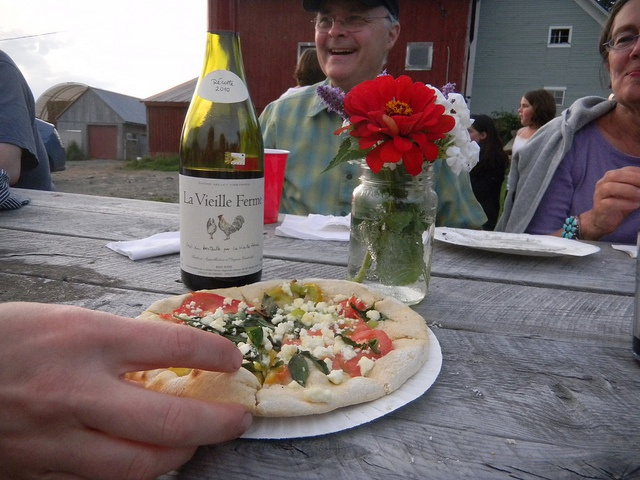Describe the objects in this image and their specific colors. I can see dining table in white, gray, and darkgray tones, people in white, brown, gray, maroon, and black tones, pizza in white, darkgray, tan, and brown tones, bottle in white, darkgray, black, gray, and maroon tones, and people in white, gray, maroon, navy, and brown tones in this image. 